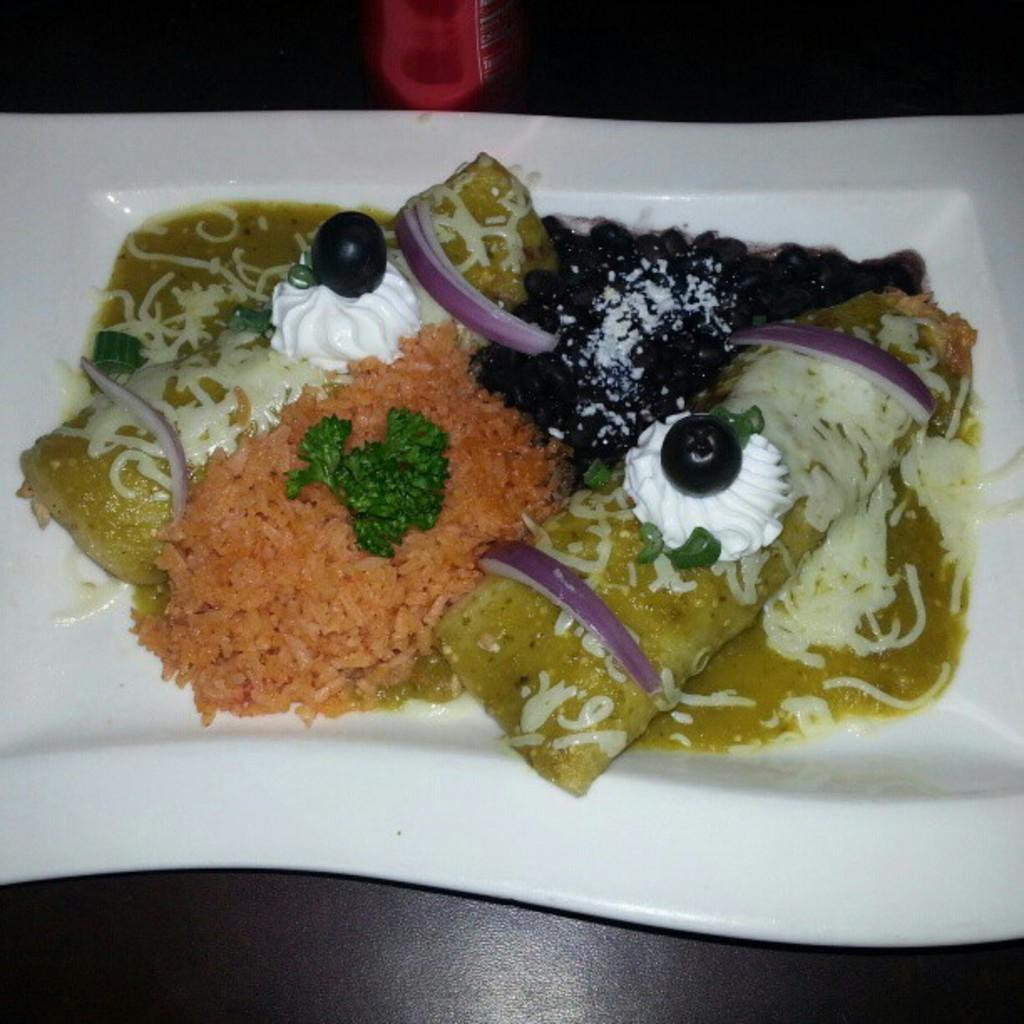What piece of furniture is present in the image? There is a table in the image. What is placed on the table? There is a white color plate on the table. What is on the plate? There is a dish on the plate. What type of flame can be seen coming from the dish on the plate? There is no flame present in the image; it is a dish on a plate. 